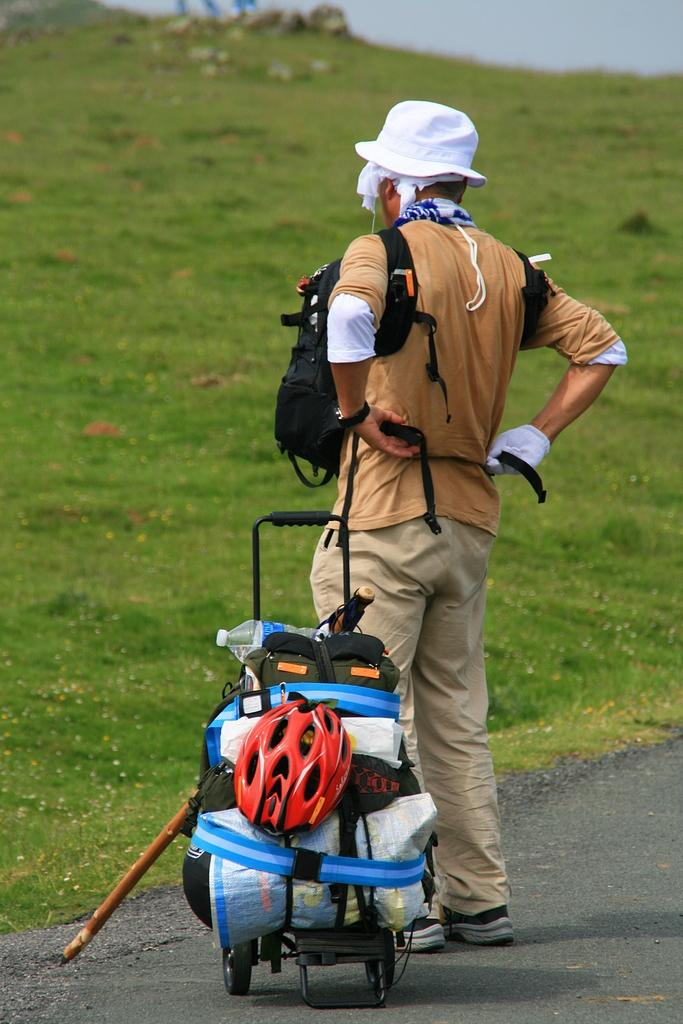What type of vegetation is present in the image? There is grass in the image. What is the man in the image doing? The man is standing on the road. What is the man holding in the image? The man is holding a suitcase. What color is the stocking on the man's leg in the image? There is no mention of a stocking or any specific color in the image. 